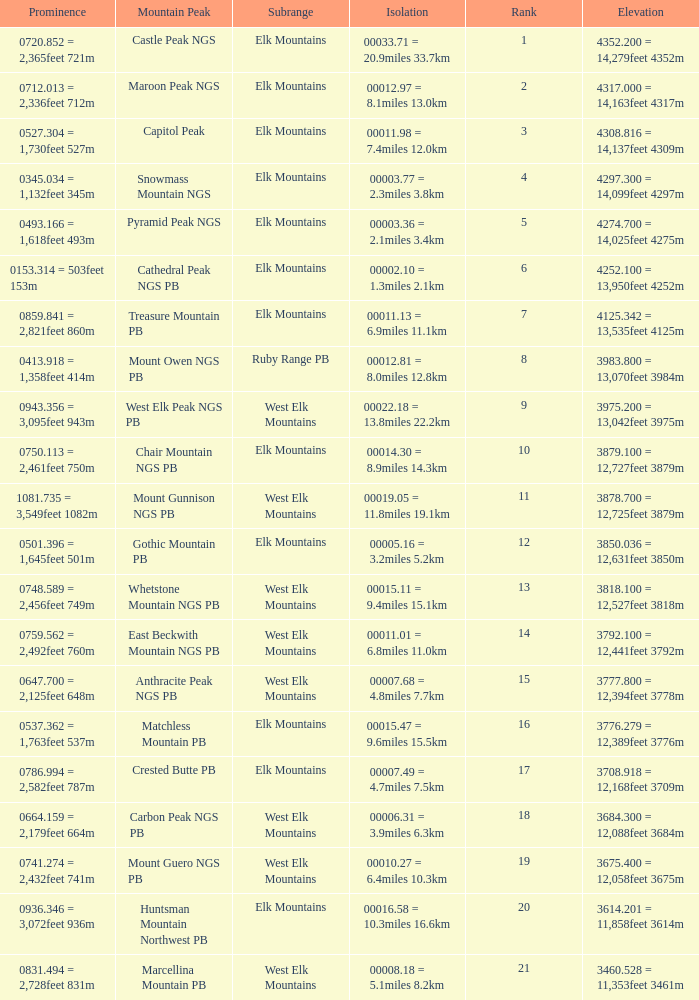Name the Rank of Rank Mountain Peak of crested butte pb? 17.0. 